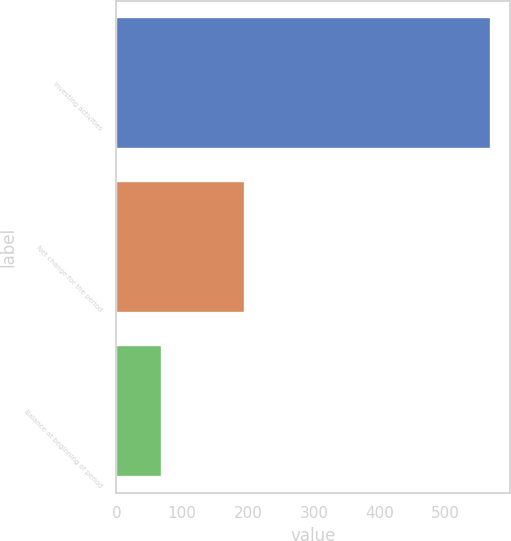Convert chart. <chart><loc_0><loc_0><loc_500><loc_500><bar_chart><fcel>Investing activities<fcel>Net change for the period<fcel>Balance at beginning of period<nl><fcel>569<fcel>195<fcel>70<nl></chart> 